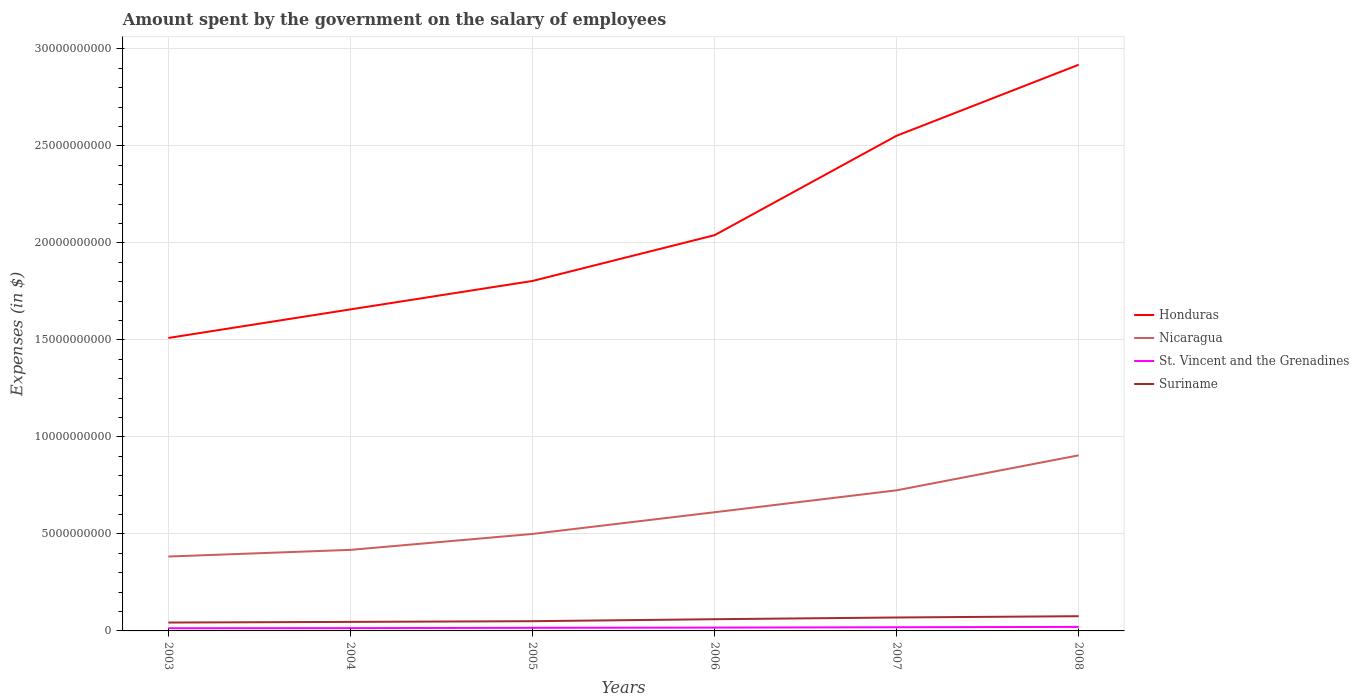How many different coloured lines are there?
Make the answer very short. 4. Across all years, what is the maximum amount spent on the salary of employees by the government in St. Vincent and the Grenadines?
Offer a terse response. 1.39e+08. What is the total amount spent on the salary of employees by the government in Suriname in the graph?
Your answer should be very brief. -2.57e+08. What is the difference between the highest and the second highest amount spent on the salary of employees by the government in Suriname?
Your answer should be very brief. 3.27e+08. What is the difference between the highest and the lowest amount spent on the salary of employees by the government in St. Vincent and the Grenadines?
Provide a short and direct response. 3. Is the amount spent on the salary of employees by the government in St. Vincent and the Grenadines strictly greater than the amount spent on the salary of employees by the government in Suriname over the years?
Your response must be concise. Yes. How many lines are there?
Provide a short and direct response. 4. What is the difference between two consecutive major ticks on the Y-axis?
Your answer should be compact. 5.00e+09. Does the graph contain grids?
Offer a very short reply. Yes. How are the legend labels stacked?
Provide a succinct answer. Vertical. What is the title of the graph?
Make the answer very short. Amount spent by the government on the salary of employees. Does "Sub-Saharan Africa (all income levels)" appear as one of the legend labels in the graph?
Your answer should be compact. No. What is the label or title of the X-axis?
Give a very brief answer. Years. What is the label or title of the Y-axis?
Offer a very short reply. Expenses (in $). What is the Expenses (in $) in Honduras in 2003?
Ensure brevity in your answer.  1.51e+1. What is the Expenses (in $) of Nicaragua in 2003?
Your answer should be compact. 3.83e+09. What is the Expenses (in $) of St. Vincent and the Grenadines in 2003?
Your response must be concise. 1.39e+08. What is the Expenses (in $) of Suriname in 2003?
Your answer should be very brief. 4.32e+08. What is the Expenses (in $) in Honduras in 2004?
Make the answer very short. 1.66e+1. What is the Expenses (in $) in Nicaragua in 2004?
Give a very brief answer. 4.18e+09. What is the Expenses (in $) in St. Vincent and the Grenadines in 2004?
Keep it short and to the point. 1.45e+08. What is the Expenses (in $) in Suriname in 2004?
Your response must be concise. 4.65e+08. What is the Expenses (in $) in Honduras in 2005?
Your answer should be very brief. 1.80e+1. What is the Expenses (in $) of Nicaragua in 2005?
Provide a succinct answer. 5.00e+09. What is the Expenses (in $) in St. Vincent and the Grenadines in 2005?
Your answer should be very brief. 1.59e+08. What is the Expenses (in $) of Suriname in 2005?
Provide a short and direct response. 5.02e+08. What is the Expenses (in $) in Honduras in 2006?
Provide a short and direct response. 2.04e+1. What is the Expenses (in $) of Nicaragua in 2006?
Provide a succinct answer. 6.12e+09. What is the Expenses (in $) of St. Vincent and the Grenadines in 2006?
Provide a short and direct response. 1.71e+08. What is the Expenses (in $) in Suriname in 2006?
Your answer should be very brief. 6.03e+08. What is the Expenses (in $) of Honduras in 2007?
Give a very brief answer. 2.55e+1. What is the Expenses (in $) in Nicaragua in 2007?
Give a very brief answer. 7.25e+09. What is the Expenses (in $) of St. Vincent and the Grenadines in 2007?
Offer a terse response. 1.89e+08. What is the Expenses (in $) in Suriname in 2007?
Ensure brevity in your answer.  6.92e+08. What is the Expenses (in $) of Honduras in 2008?
Offer a very short reply. 2.92e+1. What is the Expenses (in $) of Nicaragua in 2008?
Offer a very short reply. 9.05e+09. What is the Expenses (in $) in St. Vincent and the Grenadines in 2008?
Your response must be concise. 2.07e+08. What is the Expenses (in $) of Suriname in 2008?
Your answer should be compact. 7.59e+08. Across all years, what is the maximum Expenses (in $) of Honduras?
Offer a terse response. 2.92e+1. Across all years, what is the maximum Expenses (in $) in Nicaragua?
Ensure brevity in your answer.  9.05e+09. Across all years, what is the maximum Expenses (in $) in St. Vincent and the Grenadines?
Offer a terse response. 2.07e+08. Across all years, what is the maximum Expenses (in $) in Suriname?
Provide a succinct answer. 7.59e+08. Across all years, what is the minimum Expenses (in $) of Honduras?
Your answer should be compact. 1.51e+1. Across all years, what is the minimum Expenses (in $) of Nicaragua?
Give a very brief answer. 3.83e+09. Across all years, what is the minimum Expenses (in $) in St. Vincent and the Grenadines?
Your answer should be very brief. 1.39e+08. Across all years, what is the minimum Expenses (in $) in Suriname?
Ensure brevity in your answer.  4.32e+08. What is the total Expenses (in $) in Honduras in the graph?
Your answer should be very brief. 1.25e+11. What is the total Expenses (in $) in Nicaragua in the graph?
Ensure brevity in your answer.  3.54e+1. What is the total Expenses (in $) of St. Vincent and the Grenadines in the graph?
Provide a succinct answer. 1.01e+09. What is the total Expenses (in $) of Suriname in the graph?
Provide a short and direct response. 3.45e+09. What is the difference between the Expenses (in $) of Honduras in 2003 and that in 2004?
Make the answer very short. -1.47e+09. What is the difference between the Expenses (in $) in Nicaragua in 2003 and that in 2004?
Give a very brief answer. -3.44e+08. What is the difference between the Expenses (in $) of St. Vincent and the Grenadines in 2003 and that in 2004?
Make the answer very short. -5.70e+06. What is the difference between the Expenses (in $) of Suriname in 2003 and that in 2004?
Ensure brevity in your answer.  -3.36e+07. What is the difference between the Expenses (in $) in Honduras in 2003 and that in 2005?
Make the answer very short. -2.94e+09. What is the difference between the Expenses (in $) in Nicaragua in 2003 and that in 2005?
Ensure brevity in your answer.  -1.16e+09. What is the difference between the Expenses (in $) of St. Vincent and the Grenadines in 2003 and that in 2005?
Your answer should be compact. -2.00e+07. What is the difference between the Expenses (in $) of Suriname in 2003 and that in 2005?
Offer a very short reply. -7.01e+07. What is the difference between the Expenses (in $) of Honduras in 2003 and that in 2006?
Ensure brevity in your answer.  -5.30e+09. What is the difference between the Expenses (in $) of Nicaragua in 2003 and that in 2006?
Your response must be concise. -2.28e+09. What is the difference between the Expenses (in $) in St. Vincent and the Grenadines in 2003 and that in 2006?
Give a very brief answer. -3.22e+07. What is the difference between the Expenses (in $) in Suriname in 2003 and that in 2006?
Ensure brevity in your answer.  -1.71e+08. What is the difference between the Expenses (in $) of Honduras in 2003 and that in 2007?
Keep it short and to the point. -1.04e+1. What is the difference between the Expenses (in $) of Nicaragua in 2003 and that in 2007?
Your response must be concise. -3.41e+09. What is the difference between the Expenses (in $) in St. Vincent and the Grenadines in 2003 and that in 2007?
Make the answer very short. -4.99e+07. What is the difference between the Expenses (in $) in Suriname in 2003 and that in 2007?
Provide a short and direct response. -2.61e+08. What is the difference between the Expenses (in $) of Honduras in 2003 and that in 2008?
Ensure brevity in your answer.  -1.41e+1. What is the difference between the Expenses (in $) of Nicaragua in 2003 and that in 2008?
Make the answer very short. -5.22e+09. What is the difference between the Expenses (in $) in St. Vincent and the Grenadines in 2003 and that in 2008?
Give a very brief answer. -6.77e+07. What is the difference between the Expenses (in $) in Suriname in 2003 and that in 2008?
Offer a terse response. -3.27e+08. What is the difference between the Expenses (in $) of Honduras in 2004 and that in 2005?
Provide a succinct answer. -1.47e+09. What is the difference between the Expenses (in $) in Nicaragua in 2004 and that in 2005?
Provide a succinct answer. -8.21e+08. What is the difference between the Expenses (in $) in St. Vincent and the Grenadines in 2004 and that in 2005?
Provide a short and direct response. -1.43e+07. What is the difference between the Expenses (in $) in Suriname in 2004 and that in 2005?
Provide a succinct answer. -3.64e+07. What is the difference between the Expenses (in $) of Honduras in 2004 and that in 2006?
Give a very brief answer. -3.82e+09. What is the difference between the Expenses (in $) of Nicaragua in 2004 and that in 2006?
Provide a succinct answer. -1.94e+09. What is the difference between the Expenses (in $) of St. Vincent and the Grenadines in 2004 and that in 2006?
Offer a very short reply. -2.65e+07. What is the difference between the Expenses (in $) in Suriname in 2004 and that in 2006?
Give a very brief answer. -1.38e+08. What is the difference between the Expenses (in $) of Honduras in 2004 and that in 2007?
Provide a succinct answer. -8.95e+09. What is the difference between the Expenses (in $) in Nicaragua in 2004 and that in 2007?
Keep it short and to the point. -3.07e+09. What is the difference between the Expenses (in $) in St. Vincent and the Grenadines in 2004 and that in 2007?
Your answer should be compact. -4.42e+07. What is the difference between the Expenses (in $) of Suriname in 2004 and that in 2007?
Keep it short and to the point. -2.27e+08. What is the difference between the Expenses (in $) in Honduras in 2004 and that in 2008?
Your answer should be compact. -1.26e+1. What is the difference between the Expenses (in $) in Nicaragua in 2004 and that in 2008?
Ensure brevity in your answer.  -4.87e+09. What is the difference between the Expenses (in $) in St. Vincent and the Grenadines in 2004 and that in 2008?
Your response must be concise. -6.20e+07. What is the difference between the Expenses (in $) of Suriname in 2004 and that in 2008?
Ensure brevity in your answer.  -2.93e+08. What is the difference between the Expenses (in $) of Honduras in 2005 and that in 2006?
Offer a very short reply. -2.36e+09. What is the difference between the Expenses (in $) in Nicaragua in 2005 and that in 2006?
Your answer should be very brief. -1.12e+09. What is the difference between the Expenses (in $) in St. Vincent and the Grenadines in 2005 and that in 2006?
Make the answer very short. -1.22e+07. What is the difference between the Expenses (in $) in Suriname in 2005 and that in 2006?
Your answer should be compact. -1.01e+08. What is the difference between the Expenses (in $) in Honduras in 2005 and that in 2007?
Ensure brevity in your answer.  -7.49e+09. What is the difference between the Expenses (in $) of Nicaragua in 2005 and that in 2007?
Keep it short and to the point. -2.25e+09. What is the difference between the Expenses (in $) in St. Vincent and the Grenadines in 2005 and that in 2007?
Offer a terse response. -2.99e+07. What is the difference between the Expenses (in $) of Suriname in 2005 and that in 2007?
Your answer should be compact. -1.91e+08. What is the difference between the Expenses (in $) in Honduras in 2005 and that in 2008?
Your answer should be very brief. -1.11e+1. What is the difference between the Expenses (in $) in Nicaragua in 2005 and that in 2008?
Make the answer very short. -4.05e+09. What is the difference between the Expenses (in $) in St. Vincent and the Grenadines in 2005 and that in 2008?
Keep it short and to the point. -4.77e+07. What is the difference between the Expenses (in $) of Suriname in 2005 and that in 2008?
Your response must be concise. -2.57e+08. What is the difference between the Expenses (in $) of Honduras in 2006 and that in 2007?
Give a very brief answer. -5.13e+09. What is the difference between the Expenses (in $) in Nicaragua in 2006 and that in 2007?
Keep it short and to the point. -1.13e+09. What is the difference between the Expenses (in $) in St. Vincent and the Grenadines in 2006 and that in 2007?
Your answer should be very brief. -1.77e+07. What is the difference between the Expenses (in $) in Suriname in 2006 and that in 2007?
Your answer should be very brief. -8.94e+07. What is the difference between the Expenses (in $) of Honduras in 2006 and that in 2008?
Your response must be concise. -8.79e+09. What is the difference between the Expenses (in $) of Nicaragua in 2006 and that in 2008?
Offer a very short reply. -2.93e+09. What is the difference between the Expenses (in $) in St. Vincent and the Grenadines in 2006 and that in 2008?
Offer a terse response. -3.55e+07. What is the difference between the Expenses (in $) in Suriname in 2006 and that in 2008?
Offer a very short reply. -1.56e+08. What is the difference between the Expenses (in $) in Honduras in 2007 and that in 2008?
Keep it short and to the point. -3.66e+09. What is the difference between the Expenses (in $) of Nicaragua in 2007 and that in 2008?
Make the answer very short. -1.80e+09. What is the difference between the Expenses (in $) in St. Vincent and the Grenadines in 2007 and that in 2008?
Offer a terse response. -1.78e+07. What is the difference between the Expenses (in $) in Suriname in 2007 and that in 2008?
Ensure brevity in your answer.  -6.61e+07. What is the difference between the Expenses (in $) in Honduras in 2003 and the Expenses (in $) in Nicaragua in 2004?
Give a very brief answer. 1.09e+1. What is the difference between the Expenses (in $) of Honduras in 2003 and the Expenses (in $) of St. Vincent and the Grenadines in 2004?
Ensure brevity in your answer.  1.50e+1. What is the difference between the Expenses (in $) of Honduras in 2003 and the Expenses (in $) of Suriname in 2004?
Your answer should be compact. 1.46e+1. What is the difference between the Expenses (in $) in Nicaragua in 2003 and the Expenses (in $) in St. Vincent and the Grenadines in 2004?
Your response must be concise. 3.69e+09. What is the difference between the Expenses (in $) in Nicaragua in 2003 and the Expenses (in $) in Suriname in 2004?
Your answer should be compact. 3.37e+09. What is the difference between the Expenses (in $) of St. Vincent and the Grenadines in 2003 and the Expenses (in $) of Suriname in 2004?
Your answer should be very brief. -3.26e+08. What is the difference between the Expenses (in $) of Honduras in 2003 and the Expenses (in $) of Nicaragua in 2005?
Make the answer very short. 1.01e+1. What is the difference between the Expenses (in $) of Honduras in 2003 and the Expenses (in $) of St. Vincent and the Grenadines in 2005?
Your response must be concise. 1.49e+1. What is the difference between the Expenses (in $) in Honduras in 2003 and the Expenses (in $) in Suriname in 2005?
Keep it short and to the point. 1.46e+1. What is the difference between the Expenses (in $) of Nicaragua in 2003 and the Expenses (in $) of St. Vincent and the Grenadines in 2005?
Your answer should be very brief. 3.68e+09. What is the difference between the Expenses (in $) in Nicaragua in 2003 and the Expenses (in $) in Suriname in 2005?
Keep it short and to the point. 3.33e+09. What is the difference between the Expenses (in $) in St. Vincent and the Grenadines in 2003 and the Expenses (in $) in Suriname in 2005?
Your answer should be very brief. -3.63e+08. What is the difference between the Expenses (in $) of Honduras in 2003 and the Expenses (in $) of Nicaragua in 2006?
Ensure brevity in your answer.  8.98e+09. What is the difference between the Expenses (in $) of Honduras in 2003 and the Expenses (in $) of St. Vincent and the Grenadines in 2006?
Make the answer very short. 1.49e+1. What is the difference between the Expenses (in $) in Honduras in 2003 and the Expenses (in $) in Suriname in 2006?
Give a very brief answer. 1.45e+1. What is the difference between the Expenses (in $) in Nicaragua in 2003 and the Expenses (in $) in St. Vincent and the Grenadines in 2006?
Give a very brief answer. 3.66e+09. What is the difference between the Expenses (in $) in Nicaragua in 2003 and the Expenses (in $) in Suriname in 2006?
Offer a very short reply. 3.23e+09. What is the difference between the Expenses (in $) in St. Vincent and the Grenadines in 2003 and the Expenses (in $) in Suriname in 2006?
Give a very brief answer. -4.64e+08. What is the difference between the Expenses (in $) in Honduras in 2003 and the Expenses (in $) in Nicaragua in 2007?
Give a very brief answer. 7.85e+09. What is the difference between the Expenses (in $) in Honduras in 2003 and the Expenses (in $) in St. Vincent and the Grenadines in 2007?
Provide a succinct answer. 1.49e+1. What is the difference between the Expenses (in $) in Honduras in 2003 and the Expenses (in $) in Suriname in 2007?
Your answer should be very brief. 1.44e+1. What is the difference between the Expenses (in $) in Nicaragua in 2003 and the Expenses (in $) in St. Vincent and the Grenadines in 2007?
Your response must be concise. 3.65e+09. What is the difference between the Expenses (in $) in Nicaragua in 2003 and the Expenses (in $) in Suriname in 2007?
Make the answer very short. 3.14e+09. What is the difference between the Expenses (in $) in St. Vincent and the Grenadines in 2003 and the Expenses (in $) in Suriname in 2007?
Provide a succinct answer. -5.53e+08. What is the difference between the Expenses (in $) of Honduras in 2003 and the Expenses (in $) of Nicaragua in 2008?
Ensure brevity in your answer.  6.05e+09. What is the difference between the Expenses (in $) in Honduras in 2003 and the Expenses (in $) in St. Vincent and the Grenadines in 2008?
Provide a short and direct response. 1.49e+1. What is the difference between the Expenses (in $) of Honduras in 2003 and the Expenses (in $) of Suriname in 2008?
Offer a very short reply. 1.43e+1. What is the difference between the Expenses (in $) of Nicaragua in 2003 and the Expenses (in $) of St. Vincent and the Grenadines in 2008?
Offer a terse response. 3.63e+09. What is the difference between the Expenses (in $) of Nicaragua in 2003 and the Expenses (in $) of Suriname in 2008?
Your answer should be compact. 3.08e+09. What is the difference between the Expenses (in $) in St. Vincent and the Grenadines in 2003 and the Expenses (in $) in Suriname in 2008?
Your answer should be compact. -6.19e+08. What is the difference between the Expenses (in $) of Honduras in 2004 and the Expenses (in $) of Nicaragua in 2005?
Your response must be concise. 1.16e+1. What is the difference between the Expenses (in $) in Honduras in 2004 and the Expenses (in $) in St. Vincent and the Grenadines in 2005?
Keep it short and to the point. 1.64e+1. What is the difference between the Expenses (in $) in Honduras in 2004 and the Expenses (in $) in Suriname in 2005?
Give a very brief answer. 1.61e+1. What is the difference between the Expenses (in $) in Nicaragua in 2004 and the Expenses (in $) in St. Vincent and the Grenadines in 2005?
Give a very brief answer. 4.02e+09. What is the difference between the Expenses (in $) in Nicaragua in 2004 and the Expenses (in $) in Suriname in 2005?
Offer a very short reply. 3.68e+09. What is the difference between the Expenses (in $) in St. Vincent and the Grenadines in 2004 and the Expenses (in $) in Suriname in 2005?
Offer a terse response. -3.57e+08. What is the difference between the Expenses (in $) of Honduras in 2004 and the Expenses (in $) of Nicaragua in 2006?
Give a very brief answer. 1.05e+1. What is the difference between the Expenses (in $) in Honduras in 2004 and the Expenses (in $) in St. Vincent and the Grenadines in 2006?
Offer a terse response. 1.64e+1. What is the difference between the Expenses (in $) of Honduras in 2004 and the Expenses (in $) of Suriname in 2006?
Offer a very short reply. 1.60e+1. What is the difference between the Expenses (in $) in Nicaragua in 2004 and the Expenses (in $) in St. Vincent and the Grenadines in 2006?
Offer a terse response. 4.01e+09. What is the difference between the Expenses (in $) of Nicaragua in 2004 and the Expenses (in $) of Suriname in 2006?
Offer a terse response. 3.57e+09. What is the difference between the Expenses (in $) in St. Vincent and the Grenadines in 2004 and the Expenses (in $) in Suriname in 2006?
Ensure brevity in your answer.  -4.58e+08. What is the difference between the Expenses (in $) of Honduras in 2004 and the Expenses (in $) of Nicaragua in 2007?
Your response must be concise. 9.33e+09. What is the difference between the Expenses (in $) of Honduras in 2004 and the Expenses (in $) of St. Vincent and the Grenadines in 2007?
Ensure brevity in your answer.  1.64e+1. What is the difference between the Expenses (in $) in Honduras in 2004 and the Expenses (in $) in Suriname in 2007?
Offer a terse response. 1.59e+1. What is the difference between the Expenses (in $) of Nicaragua in 2004 and the Expenses (in $) of St. Vincent and the Grenadines in 2007?
Your answer should be very brief. 3.99e+09. What is the difference between the Expenses (in $) in Nicaragua in 2004 and the Expenses (in $) in Suriname in 2007?
Your response must be concise. 3.49e+09. What is the difference between the Expenses (in $) in St. Vincent and the Grenadines in 2004 and the Expenses (in $) in Suriname in 2007?
Provide a short and direct response. -5.48e+08. What is the difference between the Expenses (in $) of Honduras in 2004 and the Expenses (in $) of Nicaragua in 2008?
Your answer should be very brief. 7.52e+09. What is the difference between the Expenses (in $) of Honduras in 2004 and the Expenses (in $) of St. Vincent and the Grenadines in 2008?
Provide a short and direct response. 1.64e+1. What is the difference between the Expenses (in $) of Honduras in 2004 and the Expenses (in $) of Suriname in 2008?
Give a very brief answer. 1.58e+1. What is the difference between the Expenses (in $) in Nicaragua in 2004 and the Expenses (in $) in St. Vincent and the Grenadines in 2008?
Give a very brief answer. 3.97e+09. What is the difference between the Expenses (in $) of Nicaragua in 2004 and the Expenses (in $) of Suriname in 2008?
Your response must be concise. 3.42e+09. What is the difference between the Expenses (in $) of St. Vincent and the Grenadines in 2004 and the Expenses (in $) of Suriname in 2008?
Ensure brevity in your answer.  -6.14e+08. What is the difference between the Expenses (in $) of Honduras in 2005 and the Expenses (in $) of Nicaragua in 2006?
Your answer should be very brief. 1.19e+1. What is the difference between the Expenses (in $) of Honduras in 2005 and the Expenses (in $) of St. Vincent and the Grenadines in 2006?
Provide a succinct answer. 1.79e+1. What is the difference between the Expenses (in $) of Honduras in 2005 and the Expenses (in $) of Suriname in 2006?
Offer a very short reply. 1.74e+1. What is the difference between the Expenses (in $) in Nicaragua in 2005 and the Expenses (in $) in St. Vincent and the Grenadines in 2006?
Provide a succinct answer. 4.83e+09. What is the difference between the Expenses (in $) of Nicaragua in 2005 and the Expenses (in $) of Suriname in 2006?
Offer a very short reply. 4.40e+09. What is the difference between the Expenses (in $) in St. Vincent and the Grenadines in 2005 and the Expenses (in $) in Suriname in 2006?
Provide a succinct answer. -4.44e+08. What is the difference between the Expenses (in $) of Honduras in 2005 and the Expenses (in $) of Nicaragua in 2007?
Offer a terse response. 1.08e+1. What is the difference between the Expenses (in $) in Honduras in 2005 and the Expenses (in $) in St. Vincent and the Grenadines in 2007?
Provide a short and direct response. 1.78e+1. What is the difference between the Expenses (in $) in Honduras in 2005 and the Expenses (in $) in Suriname in 2007?
Ensure brevity in your answer.  1.73e+1. What is the difference between the Expenses (in $) in Nicaragua in 2005 and the Expenses (in $) in St. Vincent and the Grenadines in 2007?
Give a very brief answer. 4.81e+09. What is the difference between the Expenses (in $) of Nicaragua in 2005 and the Expenses (in $) of Suriname in 2007?
Make the answer very short. 4.31e+09. What is the difference between the Expenses (in $) of St. Vincent and the Grenadines in 2005 and the Expenses (in $) of Suriname in 2007?
Your answer should be very brief. -5.33e+08. What is the difference between the Expenses (in $) in Honduras in 2005 and the Expenses (in $) in Nicaragua in 2008?
Offer a terse response. 8.99e+09. What is the difference between the Expenses (in $) in Honduras in 2005 and the Expenses (in $) in St. Vincent and the Grenadines in 2008?
Give a very brief answer. 1.78e+1. What is the difference between the Expenses (in $) of Honduras in 2005 and the Expenses (in $) of Suriname in 2008?
Provide a short and direct response. 1.73e+1. What is the difference between the Expenses (in $) in Nicaragua in 2005 and the Expenses (in $) in St. Vincent and the Grenadines in 2008?
Your answer should be very brief. 4.79e+09. What is the difference between the Expenses (in $) of Nicaragua in 2005 and the Expenses (in $) of Suriname in 2008?
Your response must be concise. 4.24e+09. What is the difference between the Expenses (in $) in St. Vincent and the Grenadines in 2005 and the Expenses (in $) in Suriname in 2008?
Offer a very short reply. -5.99e+08. What is the difference between the Expenses (in $) of Honduras in 2006 and the Expenses (in $) of Nicaragua in 2007?
Offer a terse response. 1.31e+1. What is the difference between the Expenses (in $) of Honduras in 2006 and the Expenses (in $) of St. Vincent and the Grenadines in 2007?
Ensure brevity in your answer.  2.02e+1. What is the difference between the Expenses (in $) in Honduras in 2006 and the Expenses (in $) in Suriname in 2007?
Offer a very short reply. 1.97e+1. What is the difference between the Expenses (in $) in Nicaragua in 2006 and the Expenses (in $) in St. Vincent and the Grenadines in 2007?
Your response must be concise. 5.93e+09. What is the difference between the Expenses (in $) in Nicaragua in 2006 and the Expenses (in $) in Suriname in 2007?
Make the answer very short. 5.42e+09. What is the difference between the Expenses (in $) of St. Vincent and the Grenadines in 2006 and the Expenses (in $) of Suriname in 2007?
Provide a short and direct response. -5.21e+08. What is the difference between the Expenses (in $) of Honduras in 2006 and the Expenses (in $) of Nicaragua in 2008?
Your answer should be compact. 1.13e+1. What is the difference between the Expenses (in $) in Honduras in 2006 and the Expenses (in $) in St. Vincent and the Grenadines in 2008?
Give a very brief answer. 2.02e+1. What is the difference between the Expenses (in $) of Honduras in 2006 and the Expenses (in $) of Suriname in 2008?
Provide a short and direct response. 1.96e+1. What is the difference between the Expenses (in $) in Nicaragua in 2006 and the Expenses (in $) in St. Vincent and the Grenadines in 2008?
Your answer should be compact. 5.91e+09. What is the difference between the Expenses (in $) of Nicaragua in 2006 and the Expenses (in $) of Suriname in 2008?
Offer a terse response. 5.36e+09. What is the difference between the Expenses (in $) of St. Vincent and the Grenadines in 2006 and the Expenses (in $) of Suriname in 2008?
Your answer should be very brief. -5.87e+08. What is the difference between the Expenses (in $) in Honduras in 2007 and the Expenses (in $) in Nicaragua in 2008?
Your response must be concise. 1.65e+1. What is the difference between the Expenses (in $) of Honduras in 2007 and the Expenses (in $) of St. Vincent and the Grenadines in 2008?
Provide a succinct answer. 2.53e+1. What is the difference between the Expenses (in $) in Honduras in 2007 and the Expenses (in $) in Suriname in 2008?
Provide a succinct answer. 2.48e+1. What is the difference between the Expenses (in $) in Nicaragua in 2007 and the Expenses (in $) in St. Vincent and the Grenadines in 2008?
Your answer should be very brief. 7.04e+09. What is the difference between the Expenses (in $) of Nicaragua in 2007 and the Expenses (in $) of Suriname in 2008?
Ensure brevity in your answer.  6.49e+09. What is the difference between the Expenses (in $) of St. Vincent and the Grenadines in 2007 and the Expenses (in $) of Suriname in 2008?
Offer a terse response. -5.70e+08. What is the average Expenses (in $) in Honduras per year?
Provide a succinct answer. 2.08e+1. What is the average Expenses (in $) of Nicaragua per year?
Ensure brevity in your answer.  5.90e+09. What is the average Expenses (in $) in St. Vincent and the Grenadines per year?
Provide a succinct answer. 1.68e+08. What is the average Expenses (in $) of Suriname per year?
Provide a short and direct response. 5.75e+08. In the year 2003, what is the difference between the Expenses (in $) in Honduras and Expenses (in $) in Nicaragua?
Your response must be concise. 1.13e+1. In the year 2003, what is the difference between the Expenses (in $) in Honduras and Expenses (in $) in St. Vincent and the Grenadines?
Offer a terse response. 1.50e+1. In the year 2003, what is the difference between the Expenses (in $) in Honduras and Expenses (in $) in Suriname?
Your response must be concise. 1.47e+1. In the year 2003, what is the difference between the Expenses (in $) in Nicaragua and Expenses (in $) in St. Vincent and the Grenadines?
Keep it short and to the point. 3.70e+09. In the year 2003, what is the difference between the Expenses (in $) of Nicaragua and Expenses (in $) of Suriname?
Ensure brevity in your answer.  3.40e+09. In the year 2003, what is the difference between the Expenses (in $) of St. Vincent and the Grenadines and Expenses (in $) of Suriname?
Offer a terse response. -2.92e+08. In the year 2004, what is the difference between the Expenses (in $) of Honduras and Expenses (in $) of Nicaragua?
Your answer should be compact. 1.24e+1. In the year 2004, what is the difference between the Expenses (in $) of Honduras and Expenses (in $) of St. Vincent and the Grenadines?
Provide a short and direct response. 1.64e+1. In the year 2004, what is the difference between the Expenses (in $) of Honduras and Expenses (in $) of Suriname?
Provide a succinct answer. 1.61e+1. In the year 2004, what is the difference between the Expenses (in $) in Nicaragua and Expenses (in $) in St. Vincent and the Grenadines?
Ensure brevity in your answer.  4.03e+09. In the year 2004, what is the difference between the Expenses (in $) in Nicaragua and Expenses (in $) in Suriname?
Provide a short and direct response. 3.71e+09. In the year 2004, what is the difference between the Expenses (in $) of St. Vincent and the Grenadines and Expenses (in $) of Suriname?
Your response must be concise. -3.20e+08. In the year 2005, what is the difference between the Expenses (in $) of Honduras and Expenses (in $) of Nicaragua?
Offer a terse response. 1.30e+1. In the year 2005, what is the difference between the Expenses (in $) of Honduras and Expenses (in $) of St. Vincent and the Grenadines?
Make the answer very short. 1.79e+1. In the year 2005, what is the difference between the Expenses (in $) in Honduras and Expenses (in $) in Suriname?
Give a very brief answer. 1.75e+1. In the year 2005, what is the difference between the Expenses (in $) in Nicaragua and Expenses (in $) in St. Vincent and the Grenadines?
Offer a very short reply. 4.84e+09. In the year 2005, what is the difference between the Expenses (in $) in Nicaragua and Expenses (in $) in Suriname?
Provide a short and direct response. 4.50e+09. In the year 2005, what is the difference between the Expenses (in $) of St. Vincent and the Grenadines and Expenses (in $) of Suriname?
Offer a very short reply. -3.43e+08. In the year 2006, what is the difference between the Expenses (in $) of Honduras and Expenses (in $) of Nicaragua?
Offer a terse response. 1.43e+1. In the year 2006, what is the difference between the Expenses (in $) of Honduras and Expenses (in $) of St. Vincent and the Grenadines?
Give a very brief answer. 2.02e+1. In the year 2006, what is the difference between the Expenses (in $) of Honduras and Expenses (in $) of Suriname?
Keep it short and to the point. 1.98e+1. In the year 2006, what is the difference between the Expenses (in $) in Nicaragua and Expenses (in $) in St. Vincent and the Grenadines?
Keep it short and to the point. 5.95e+09. In the year 2006, what is the difference between the Expenses (in $) in Nicaragua and Expenses (in $) in Suriname?
Give a very brief answer. 5.51e+09. In the year 2006, what is the difference between the Expenses (in $) of St. Vincent and the Grenadines and Expenses (in $) of Suriname?
Provide a short and direct response. -4.32e+08. In the year 2007, what is the difference between the Expenses (in $) in Honduras and Expenses (in $) in Nicaragua?
Give a very brief answer. 1.83e+1. In the year 2007, what is the difference between the Expenses (in $) in Honduras and Expenses (in $) in St. Vincent and the Grenadines?
Your answer should be compact. 2.53e+1. In the year 2007, what is the difference between the Expenses (in $) of Honduras and Expenses (in $) of Suriname?
Your response must be concise. 2.48e+1. In the year 2007, what is the difference between the Expenses (in $) of Nicaragua and Expenses (in $) of St. Vincent and the Grenadines?
Make the answer very short. 7.06e+09. In the year 2007, what is the difference between the Expenses (in $) in Nicaragua and Expenses (in $) in Suriname?
Keep it short and to the point. 6.55e+09. In the year 2007, what is the difference between the Expenses (in $) in St. Vincent and the Grenadines and Expenses (in $) in Suriname?
Make the answer very short. -5.03e+08. In the year 2008, what is the difference between the Expenses (in $) of Honduras and Expenses (in $) of Nicaragua?
Ensure brevity in your answer.  2.01e+1. In the year 2008, what is the difference between the Expenses (in $) in Honduras and Expenses (in $) in St. Vincent and the Grenadines?
Your answer should be compact. 2.90e+1. In the year 2008, what is the difference between the Expenses (in $) in Honduras and Expenses (in $) in Suriname?
Offer a very short reply. 2.84e+1. In the year 2008, what is the difference between the Expenses (in $) of Nicaragua and Expenses (in $) of St. Vincent and the Grenadines?
Offer a very short reply. 8.84e+09. In the year 2008, what is the difference between the Expenses (in $) of Nicaragua and Expenses (in $) of Suriname?
Give a very brief answer. 8.29e+09. In the year 2008, what is the difference between the Expenses (in $) in St. Vincent and the Grenadines and Expenses (in $) in Suriname?
Your answer should be compact. -5.52e+08. What is the ratio of the Expenses (in $) in Honduras in 2003 to that in 2004?
Your answer should be compact. 0.91. What is the ratio of the Expenses (in $) in Nicaragua in 2003 to that in 2004?
Your response must be concise. 0.92. What is the ratio of the Expenses (in $) in St. Vincent and the Grenadines in 2003 to that in 2004?
Ensure brevity in your answer.  0.96. What is the ratio of the Expenses (in $) in Suriname in 2003 to that in 2004?
Your response must be concise. 0.93. What is the ratio of the Expenses (in $) of Honduras in 2003 to that in 2005?
Your response must be concise. 0.84. What is the ratio of the Expenses (in $) in Nicaragua in 2003 to that in 2005?
Keep it short and to the point. 0.77. What is the ratio of the Expenses (in $) in St. Vincent and the Grenadines in 2003 to that in 2005?
Keep it short and to the point. 0.87. What is the ratio of the Expenses (in $) of Suriname in 2003 to that in 2005?
Ensure brevity in your answer.  0.86. What is the ratio of the Expenses (in $) of Honduras in 2003 to that in 2006?
Give a very brief answer. 0.74. What is the ratio of the Expenses (in $) in Nicaragua in 2003 to that in 2006?
Make the answer very short. 0.63. What is the ratio of the Expenses (in $) in St. Vincent and the Grenadines in 2003 to that in 2006?
Give a very brief answer. 0.81. What is the ratio of the Expenses (in $) of Suriname in 2003 to that in 2006?
Provide a succinct answer. 0.72. What is the ratio of the Expenses (in $) in Honduras in 2003 to that in 2007?
Make the answer very short. 0.59. What is the ratio of the Expenses (in $) in Nicaragua in 2003 to that in 2007?
Make the answer very short. 0.53. What is the ratio of the Expenses (in $) of St. Vincent and the Grenadines in 2003 to that in 2007?
Give a very brief answer. 0.74. What is the ratio of the Expenses (in $) of Suriname in 2003 to that in 2007?
Ensure brevity in your answer.  0.62. What is the ratio of the Expenses (in $) of Honduras in 2003 to that in 2008?
Provide a succinct answer. 0.52. What is the ratio of the Expenses (in $) of Nicaragua in 2003 to that in 2008?
Ensure brevity in your answer.  0.42. What is the ratio of the Expenses (in $) in St. Vincent and the Grenadines in 2003 to that in 2008?
Provide a short and direct response. 0.67. What is the ratio of the Expenses (in $) of Suriname in 2003 to that in 2008?
Provide a short and direct response. 0.57. What is the ratio of the Expenses (in $) in Honduras in 2004 to that in 2005?
Ensure brevity in your answer.  0.92. What is the ratio of the Expenses (in $) in Nicaragua in 2004 to that in 2005?
Make the answer very short. 0.84. What is the ratio of the Expenses (in $) of St. Vincent and the Grenadines in 2004 to that in 2005?
Offer a terse response. 0.91. What is the ratio of the Expenses (in $) of Suriname in 2004 to that in 2005?
Offer a terse response. 0.93. What is the ratio of the Expenses (in $) of Honduras in 2004 to that in 2006?
Offer a terse response. 0.81. What is the ratio of the Expenses (in $) of Nicaragua in 2004 to that in 2006?
Make the answer very short. 0.68. What is the ratio of the Expenses (in $) of St. Vincent and the Grenadines in 2004 to that in 2006?
Your response must be concise. 0.85. What is the ratio of the Expenses (in $) in Suriname in 2004 to that in 2006?
Give a very brief answer. 0.77. What is the ratio of the Expenses (in $) of Honduras in 2004 to that in 2007?
Offer a very short reply. 0.65. What is the ratio of the Expenses (in $) of Nicaragua in 2004 to that in 2007?
Offer a very short reply. 0.58. What is the ratio of the Expenses (in $) of St. Vincent and the Grenadines in 2004 to that in 2007?
Ensure brevity in your answer.  0.77. What is the ratio of the Expenses (in $) of Suriname in 2004 to that in 2007?
Your answer should be very brief. 0.67. What is the ratio of the Expenses (in $) of Honduras in 2004 to that in 2008?
Your response must be concise. 0.57. What is the ratio of the Expenses (in $) in Nicaragua in 2004 to that in 2008?
Your response must be concise. 0.46. What is the ratio of the Expenses (in $) of St. Vincent and the Grenadines in 2004 to that in 2008?
Offer a terse response. 0.7. What is the ratio of the Expenses (in $) of Suriname in 2004 to that in 2008?
Keep it short and to the point. 0.61. What is the ratio of the Expenses (in $) of Honduras in 2005 to that in 2006?
Keep it short and to the point. 0.88. What is the ratio of the Expenses (in $) of Nicaragua in 2005 to that in 2006?
Make the answer very short. 0.82. What is the ratio of the Expenses (in $) of St. Vincent and the Grenadines in 2005 to that in 2006?
Provide a short and direct response. 0.93. What is the ratio of the Expenses (in $) in Suriname in 2005 to that in 2006?
Your answer should be very brief. 0.83. What is the ratio of the Expenses (in $) of Honduras in 2005 to that in 2007?
Offer a very short reply. 0.71. What is the ratio of the Expenses (in $) in Nicaragua in 2005 to that in 2007?
Provide a short and direct response. 0.69. What is the ratio of the Expenses (in $) in St. Vincent and the Grenadines in 2005 to that in 2007?
Offer a very short reply. 0.84. What is the ratio of the Expenses (in $) in Suriname in 2005 to that in 2007?
Your answer should be very brief. 0.72. What is the ratio of the Expenses (in $) in Honduras in 2005 to that in 2008?
Your answer should be very brief. 0.62. What is the ratio of the Expenses (in $) of Nicaragua in 2005 to that in 2008?
Offer a very short reply. 0.55. What is the ratio of the Expenses (in $) in St. Vincent and the Grenadines in 2005 to that in 2008?
Give a very brief answer. 0.77. What is the ratio of the Expenses (in $) of Suriname in 2005 to that in 2008?
Ensure brevity in your answer.  0.66. What is the ratio of the Expenses (in $) of Honduras in 2006 to that in 2007?
Make the answer very short. 0.8. What is the ratio of the Expenses (in $) of Nicaragua in 2006 to that in 2007?
Your answer should be compact. 0.84. What is the ratio of the Expenses (in $) in St. Vincent and the Grenadines in 2006 to that in 2007?
Your answer should be very brief. 0.91. What is the ratio of the Expenses (in $) of Suriname in 2006 to that in 2007?
Your answer should be very brief. 0.87. What is the ratio of the Expenses (in $) of Honduras in 2006 to that in 2008?
Provide a succinct answer. 0.7. What is the ratio of the Expenses (in $) of Nicaragua in 2006 to that in 2008?
Your answer should be compact. 0.68. What is the ratio of the Expenses (in $) in St. Vincent and the Grenadines in 2006 to that in 2008?
Give a very brief answer. 0.83. What is the ratio of the Expenses (in $) of Suriname in 2006 to that in 2008?
Your answer should be very brief. 0.8. What is the ratio of the Expenses (in $) of Honduras in 2007 to that in 2008?
Offer a very short reply. 0.87. What is the ratio of the Expenses (in $) of Nicaragua in 2007 to that in 2008?
Your response must be concise. 0.8. What is the ratio of the Expenses (in $) of St. Vincent and the Grenadines in 2007 to that in 2008?
Provide a short and direct response. 0.91. What is the ratio of the Expenses (in $) of Suriname in 2007 to that in 2008?
Your answer should be compact. 0.91. What is the difference between the highest and the second highest Expenses (in $) in Honduras?
Offer a terse response. 3.66e+09. What is the difference between the highest and the second highest Expenses (in $) of Nicaragua?
Offer a very short reply. 1.80e+09. What is the difference between the highest and the second highest Expenses (in $) of St. Vincent and the Grenadines?
Your response must be concise. 1.78e+07. What is the difference between the highest and the second highest Expenses (in $) in Suriname?
Your answer should be compact. 6.61e+07. What is the difference between the highest and the lowest Expenses (in $) of Honduras?
Your answer should be compact. 1.41e+1. What is the difference between the highest and the lowest Expenses (in $) in Nicaragua?
Your answer should be very brief. 5.22e+09. What is the difference between the highest and the lowest Expenses (in $) of St. Vincent and the Grenadines?
Provide a short and direct response. 6.77e+07. What is the difference between the highest and the lowest Expenses (in $) of Suriname?
Offer a very short reply. 3.27e+08. 